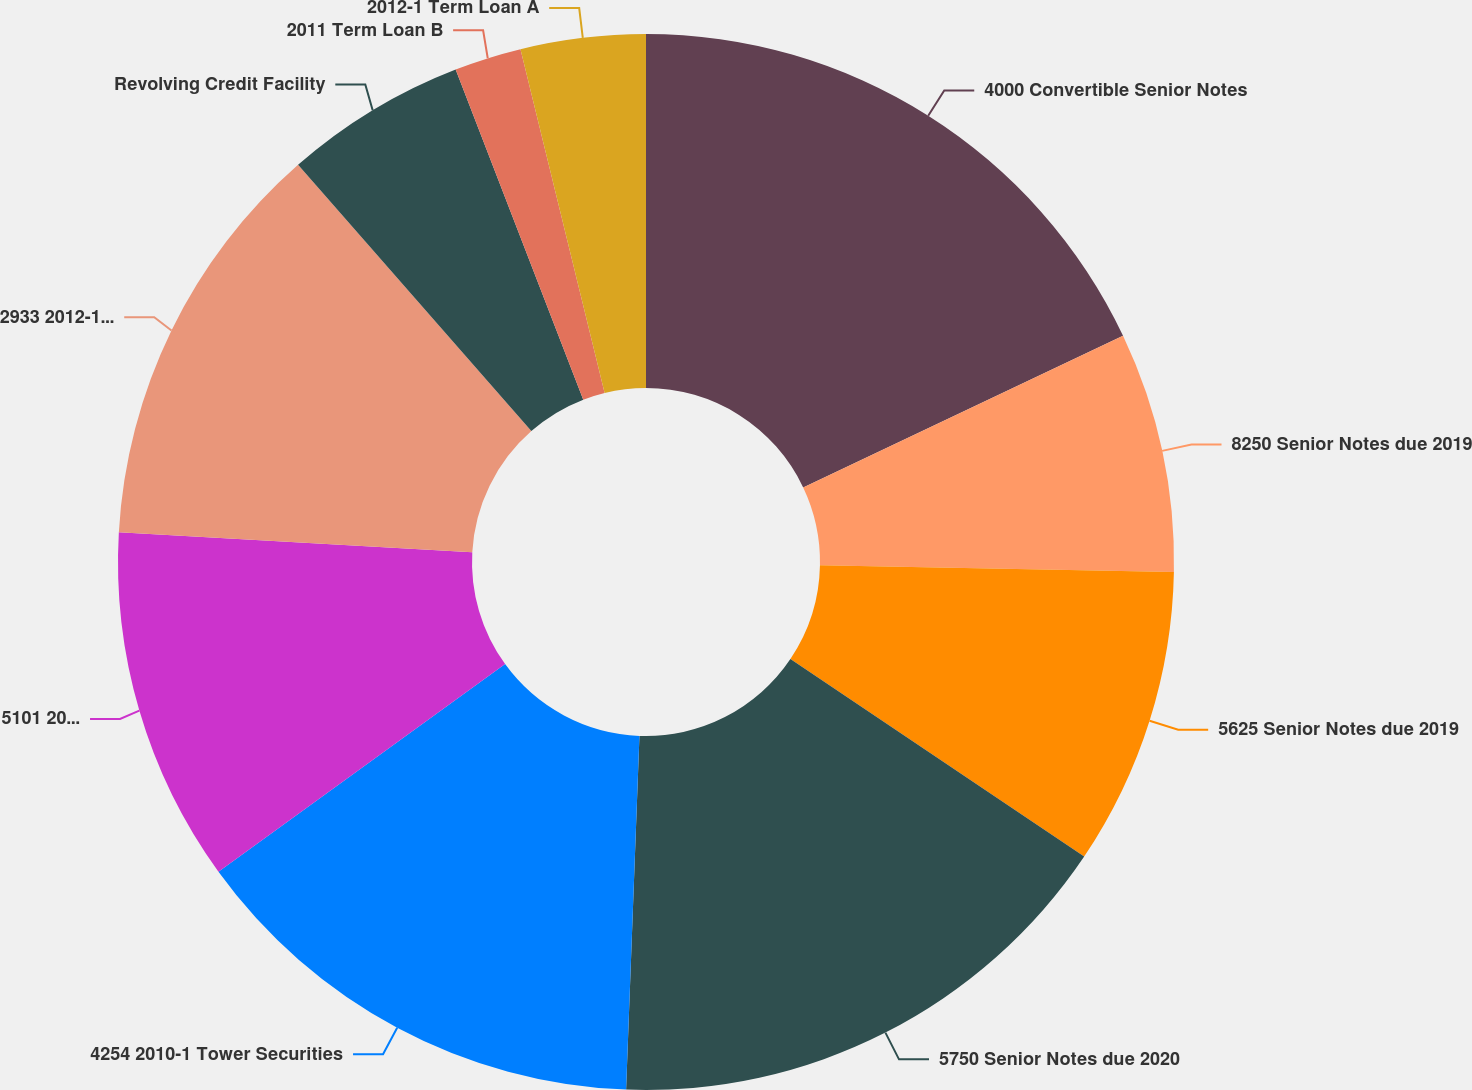Convert chart to OTSL. <chart><loc_0><loc_0><loc_500><loc_500><pie_chart><fcel>4000 Convertible Senior Notes<fcel>8250 Senior Notes due 2019<fcel>5625 Senior Notes due 2019<fcel>5750 Senior Notes due 2020<fcel>4254 2010-1 Tower Securities<fcel>5101 2010-2 Tower Securities<fcel>2933 2012-1Tower Securities<fcel>Revolving Credit Facility<fcel>2011 Term Loan B<fcel>2012-1 Term Loan A<nl><fcel>17.95%<fcel>7.35%<fcel>9.12%<fcel>16.18%<fcel>14.42%<fcel>10.88%<fcel>12.65%<fcel>5.58%<fcel>2.05%<fcel>3.82%<nl></chart> 